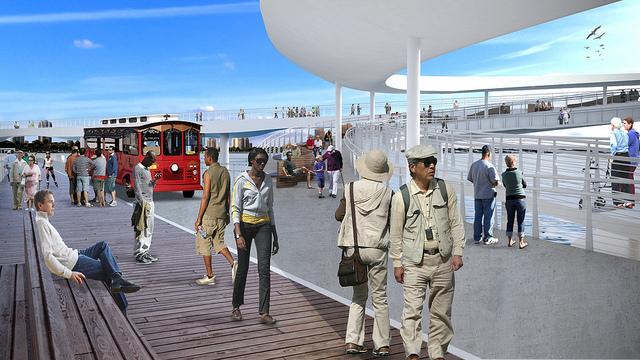How many people are shown?
Keep it brief. 67. How many children are in the scene?
Give a very brief answer. 1. What color is the trolley car?
Give a very brief answer. Red. 